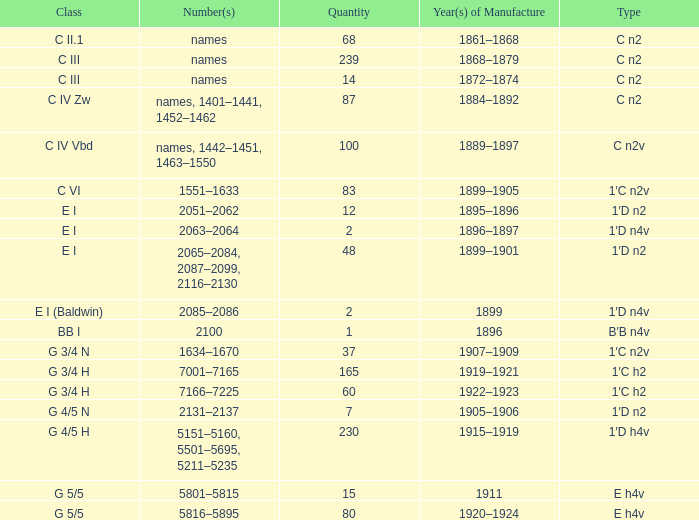Which Year(s) of Manufacture has a Quantity larger than 60, and a Number(s) of 7001–7165? 1919–1921. 